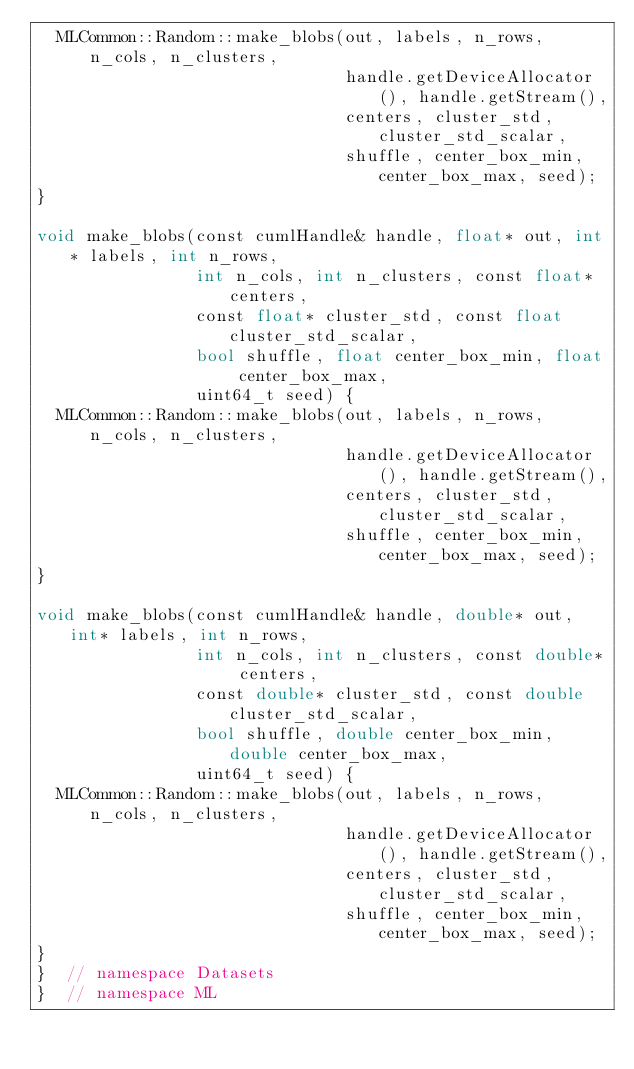Convert code to text. <code><loc_0><loc_0><loc_500><loc_500><_Cuda_>  MLCommon::Random::make_blobs(out, labels, n_rows, n_cols, n_clusters,
                               handle.getDeviceAllocator(), handle.getStream(),
                               centers, cluster_std, cluster_std_scalar,
                               shuffle, center_box_min, center_box_max, seed);
}

void make_blobs(const cumlHandle& handle, float* out, int* labels, int n_rows,
                int n_cols, int n_clusters, const float* centers,
                const float* cluster_std, const float cluster_std_scalar,
                bool shuffle, float center_box_min, float center_box_max,
                uint64_t seed) {
  MLCommon::Random::make_blobs(out, labels, n_rows, n_cols, n_clusters,
                               handle.getDeviceAllocator(), handle.getStream(),
                               centers, cluster_std, cluster_std_scalar,
                               shuffle, center_box_min, center_box_max, seed);
}

void make_blobs(const cumlHandle& handle, double* out, int* labels, int n_rows,
                int n_cols, int n_clusters, const double* centers,
                const double* cluster_std, const double cluster_std_scalar,
                bool shuffle, double center_box_min, double center_box_max,
                uint64_t seed) {
  MLCommon::Random::make_blobs(out, labels, n_rows, n_cols, n_clusters,
                               handle.getDeviceAllocator(), handle.getStream(),
                               centers, cluster_std, cluster_std_scalar,
                               shuffle, center_box_min, center_box_max, seed);
}
}  // namespace Datasets
}  // namespace ML
</code> 